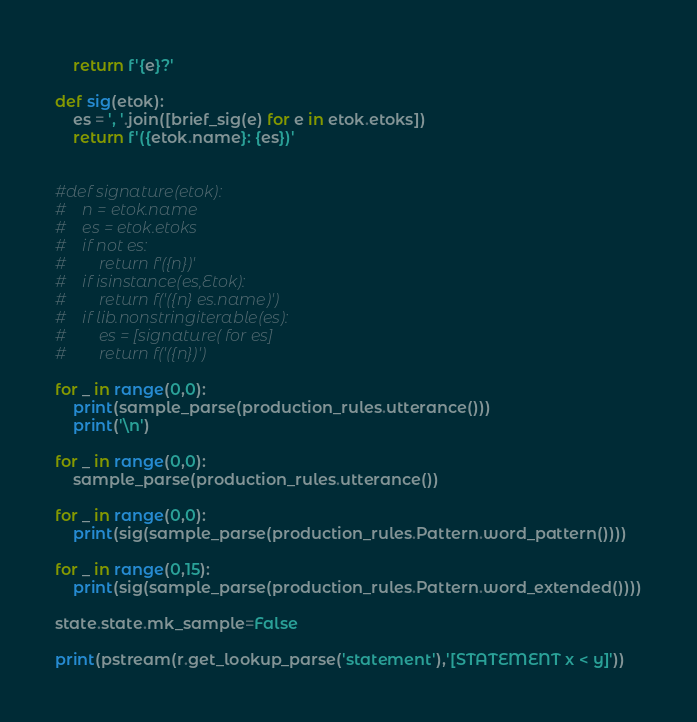Convert code to text. <code><loc_0><loc_0><loc_500><loc_500><_Python_>    return f'{e}?'

def sig(etok):
    es = ', '.join([brief_sig(e) for e in etok.etoks])
    return f'({etok.name}: {es})'
    

#def signature(etok):
#    n = etok.name 
#    es = etok.etoks 
#    if not es:
#        return f'({n})'
#    if isinstance(es,Etok):
#        return f('({n} es.name)')
#    if lib.nonstringiterable(es):
#        es = [signature( for es]
#        return f('({n})')

for _ in range(0,0):
    print(sample_parse(production_rules.utterance()))
    print('\n')
    
for _ in range(0,0):
    sample_parse(production_rules.utterance())
 
for _ in range(0,0):
    print(sig(sample_parse(production_rules.Pattern.word_pattern())))
    
for _ in range(0,15):
    print(sig(sample_parse(production_rules.Pattern.word_extended())))
    
state.state.mk_sample=False

print(pstream(r.get_lookup_parse('statement'),'[STATEMENT x < y]'))



</code> 